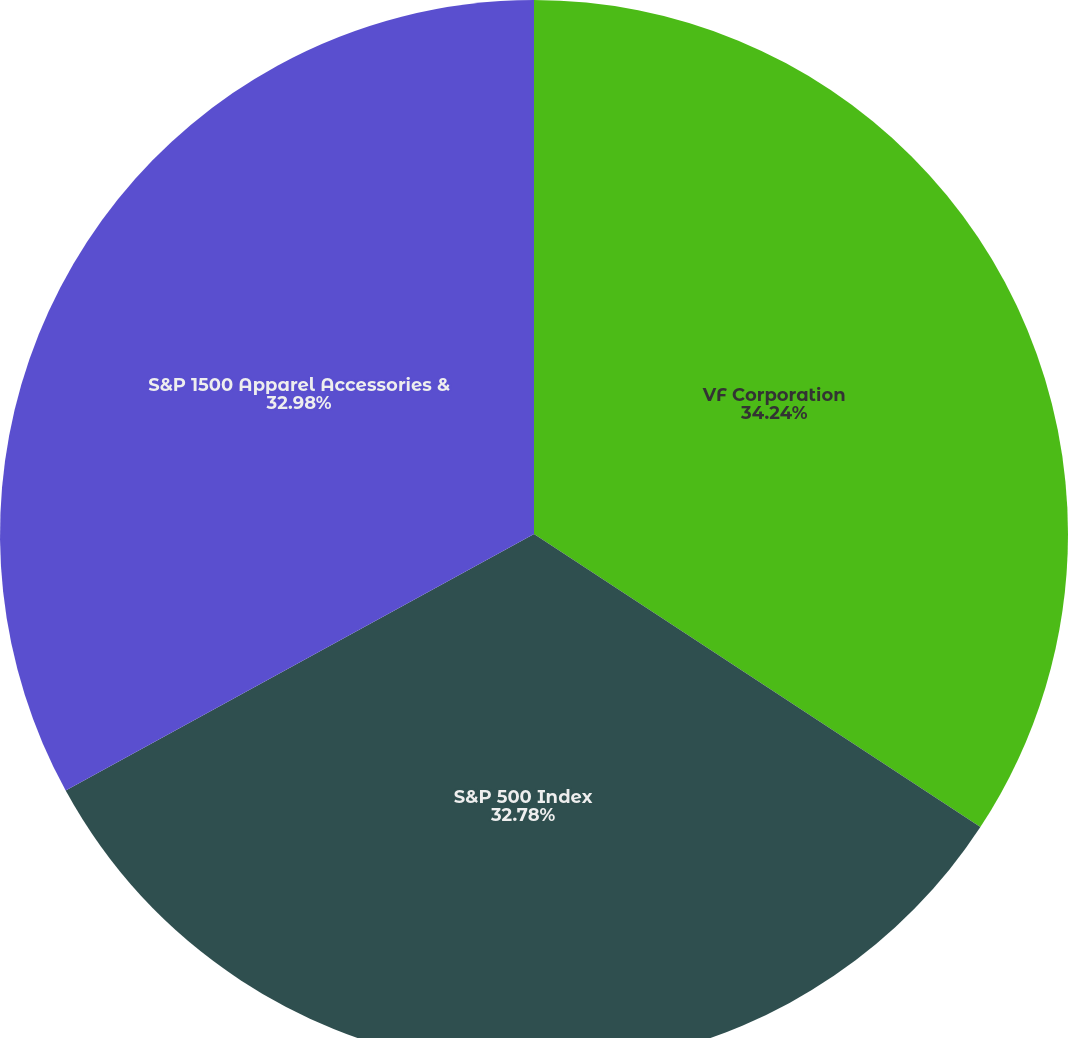<chart> <loc_0><loc_0><loc_500><loc_500><pie_chart><fcel>VF Corporation<fcel>S&P 500 Index<fcel>S&P 1500 Apparel Accessories &<nl><fcel>34.25%<fcel>32.78%<fcel>32.98%<nl></chart> 